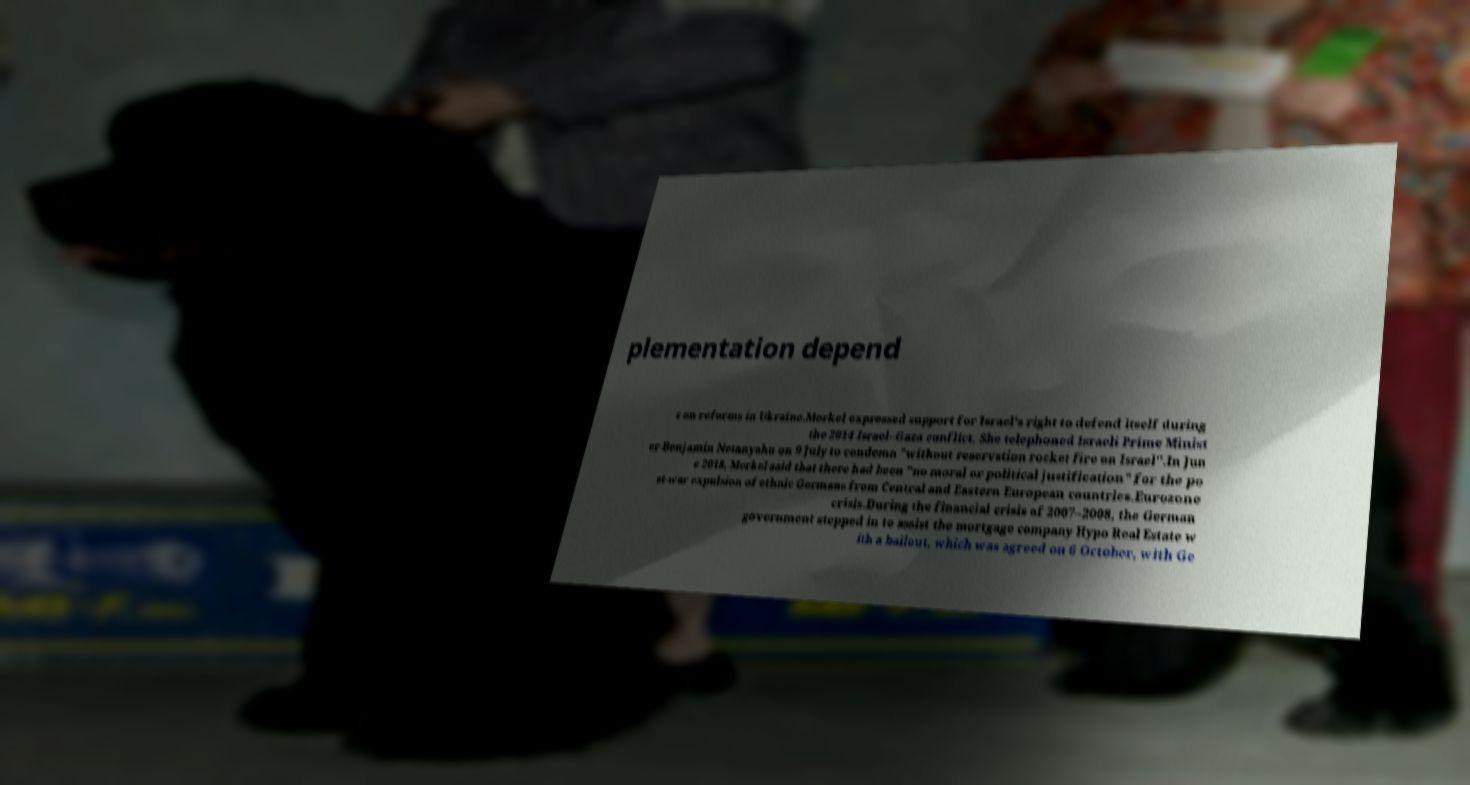Please identify and transcribe the text found in this image. plementation depend s on reforms in Ukraine.Merkel expressed support for Israel's right to defend itself during the 2014 Israel–Gaza conflict. She telephoned Israeli Prime Minist er Benjamin Netanyahu on 9 July to condemn "without reservation rocket fire on Israel".In Jun e 2018, Merkel said that there had been "no moral or political justification" for the po st-war expulsion of ethnic Germans from Central and Eastern European countries.Eurozone crisis.During the financial crisis of 2007–2008, the German government stepped in to assist the mortgage company Hypo Real Estate w ith a bailout, which was agreed on 6 October, with Ge 